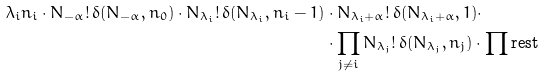Convert formula to latex. <formula><loc_0><loc_0><loc_500><loc_500>\lambda _ { i } n _ { i } \cdot N _ { - \alpha } ! \, \delta ( N _ { - \alpha } , n _ { 0 } ) \cdot N _ { \lambda _ { i } } ! \, \delta ( N _ { \lambda _ { i } } , n _ { i } - 1 ) & \cdot N _ { \lambda _ { i } + \alpha } ! \, \delta ( N _ { \lambda _ { i } + \alpha } , 1 ) \cdot \\ & \cdot \prod _ { j \neq i } N _ { \lambda _ { j } } ! \, \delta ( N _ { \lambda _ { j } } , n _ { j } ) \cdot \prod \text {rest}</formula> 